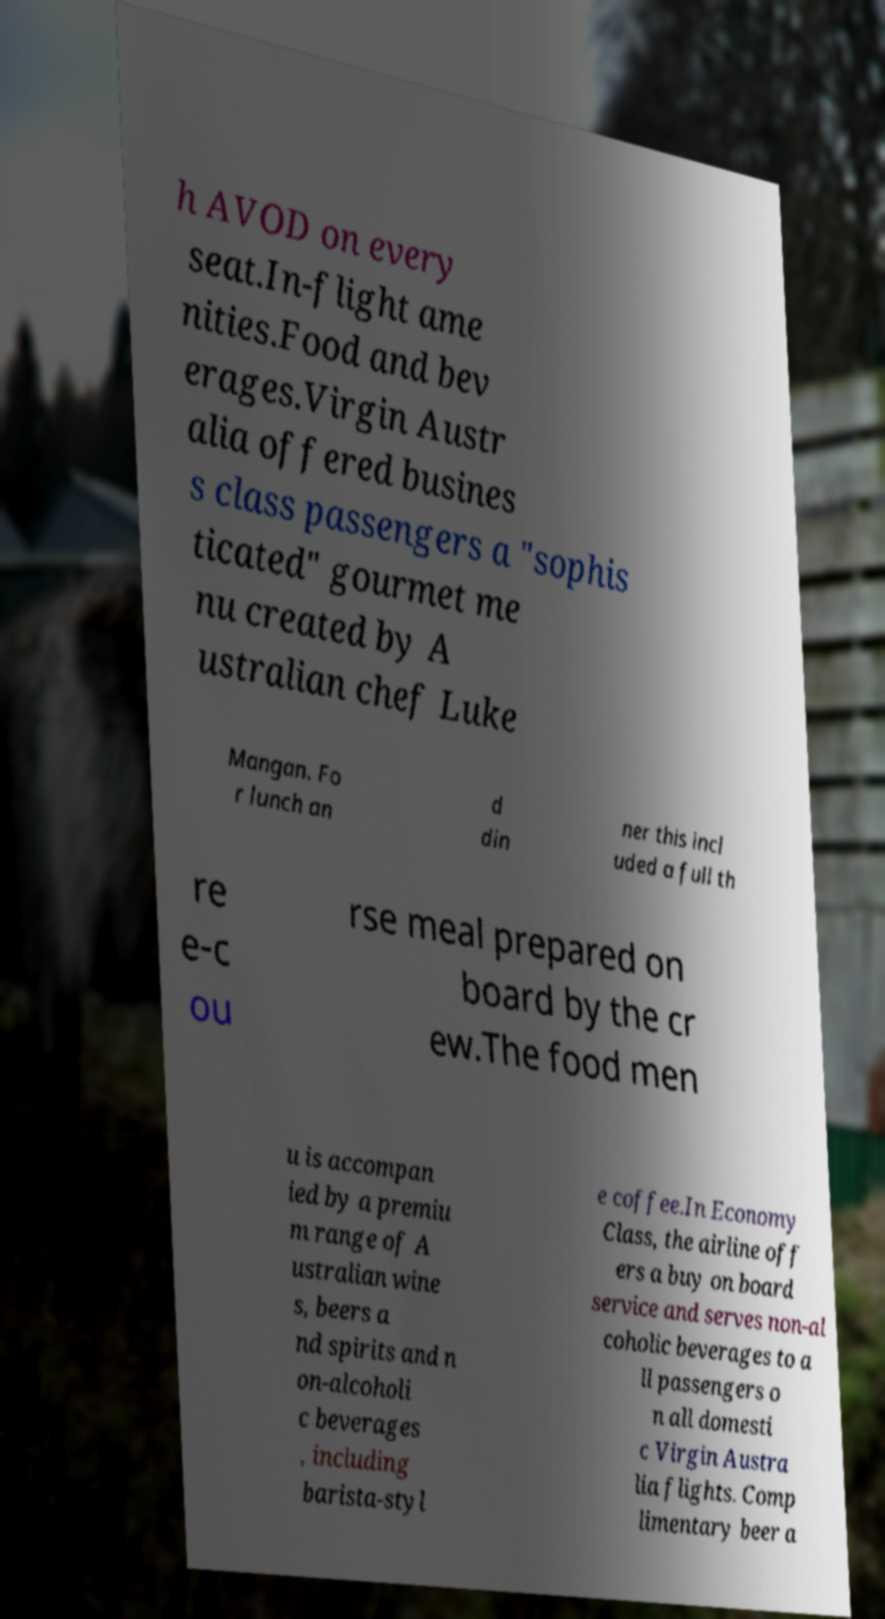Could you extract and type out the text from this image? h AVOD on every seat.In-flight ame nities.Food and bev erages.Virgin Austr alia offered busines s class passengers a "sophis ticated" gourmet me nu created by A ustralian chef Luke Mangan. Fo r lunch an d din ner this incl uded a full th re e-c ou rse meal prepared on board by the cr ew.The food men u is accompan ied by a premiu m range of A ustralian wine s, beers a nd spirits and n on-alcoholi c beverages , including barista-styl e coffee.In Economy Class, the airline off ers a buy on board service and serves non-al coholic beverages to a ll passengers o n all domesti c Virgin Austra lia flights. Comp limentary beer a 